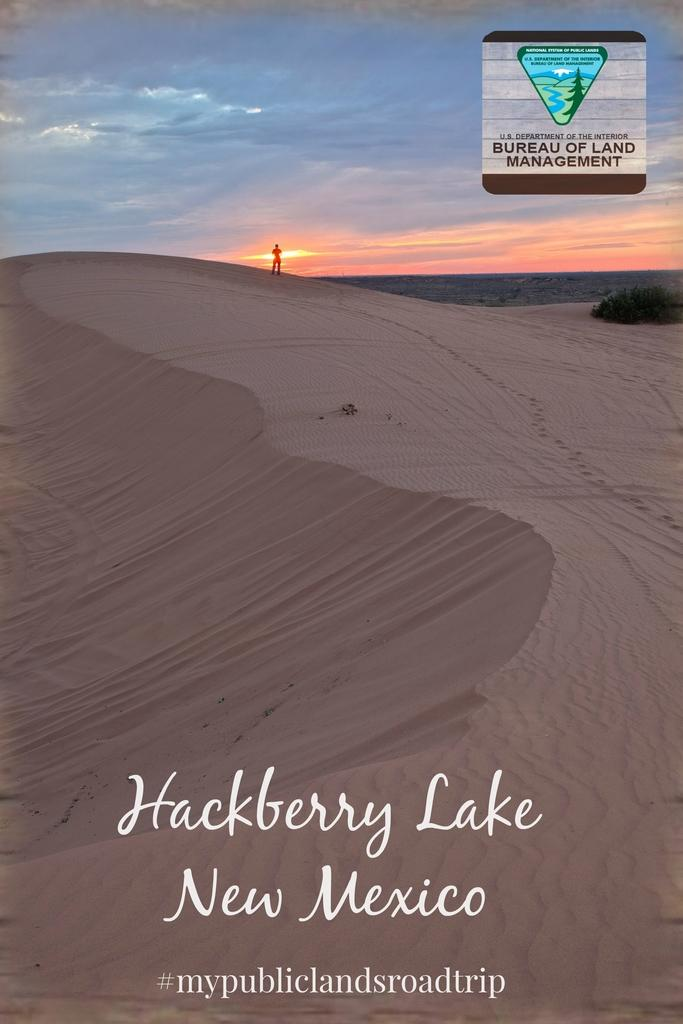<image>
Provide a brief description of the given image. The pamphlet is distributed by the Bureau of Land Management 